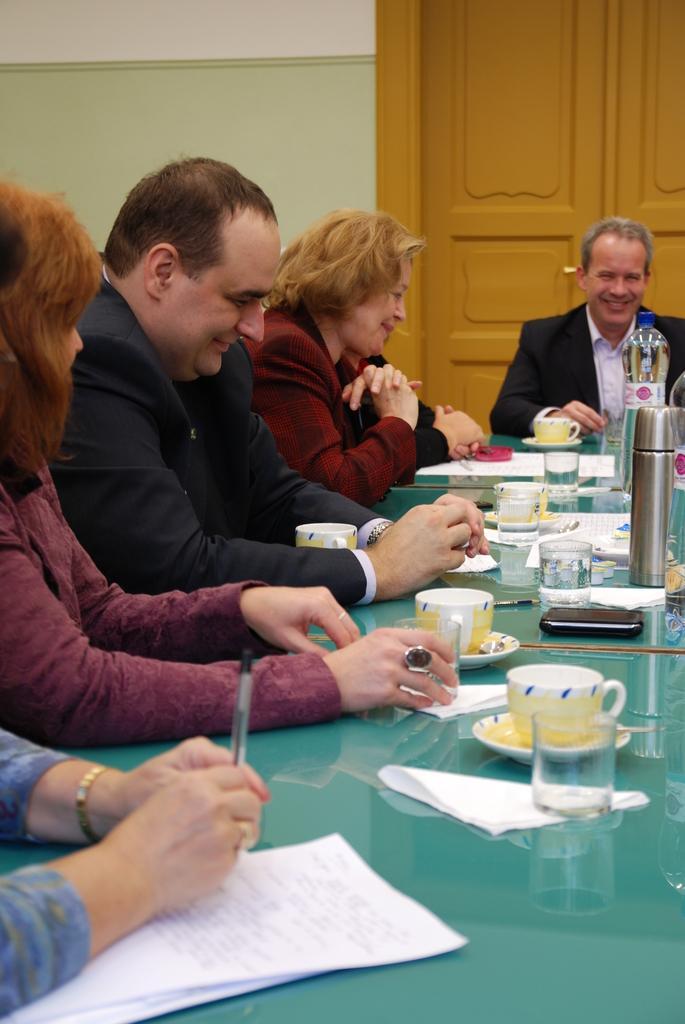Please provide a concise description of this image. In the picture we can see two men and two women are sitting near the table, on the table, we can see some cup and saucers, tissues, glasses of water and one woman is holding a pen and under her hand we can see some papers and in the background we can see a wall with a door to it. 